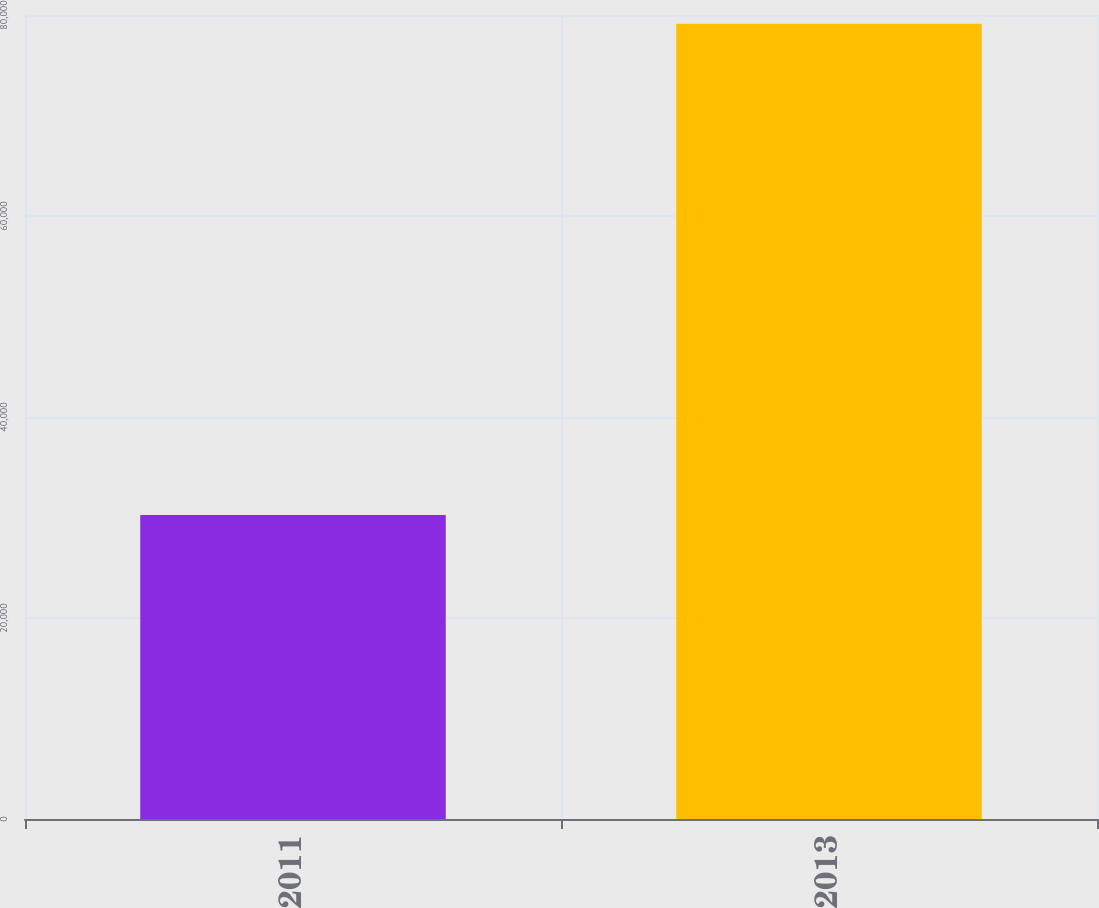Convert chart to OTSL. <chart><loc_0><loc_0><loc_500><loc_500><bar_chart><fcel>2011<fcel>2013<nl><fcel>30243<fcel>79123<nl></chart> 